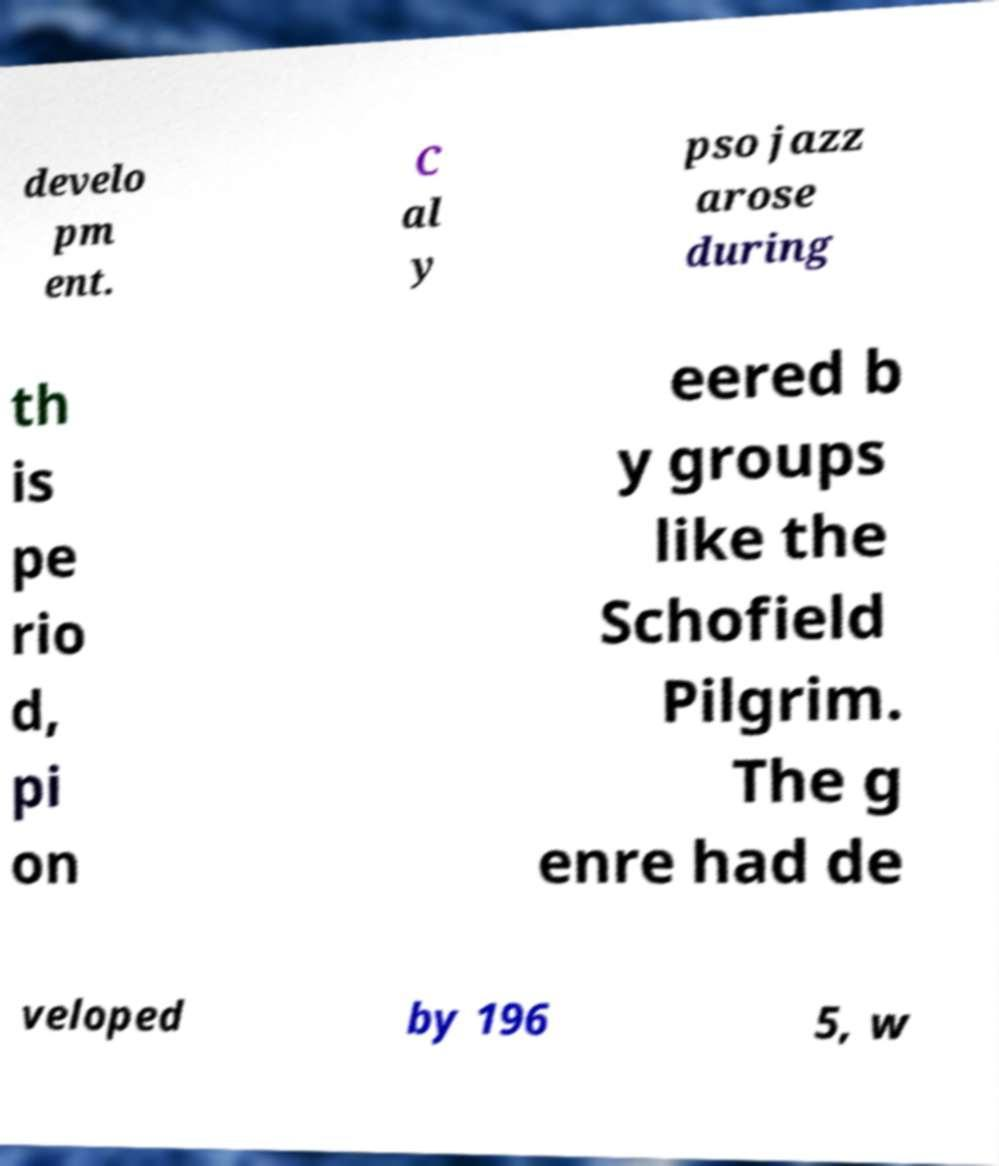Can you read and provide the text displayed in the image?This photo seems to have some interesting text. Can you extract and type it out for me? develo pm ent. C al y pso jazz arose during th is pe rio d, pi on eered b y groups like the Schofield Pilgrim. The g enre had de veloped by 196 5, w 